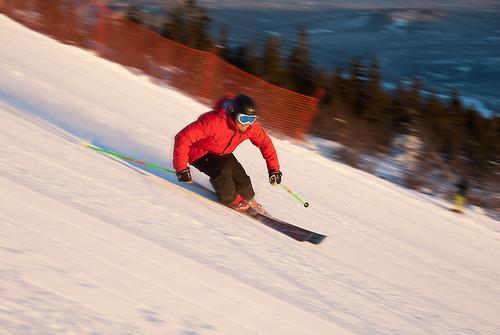How many people are visible in this photo?
Give a very brief answer. 1. 